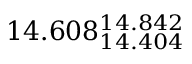<formula> <loc_0><loc_0><loc_500><loc_500>1 4 . 6 0 8 _ { 1 4 . 4 0 4 } ^ { 1 4 . 8 4 2 }</formula> 